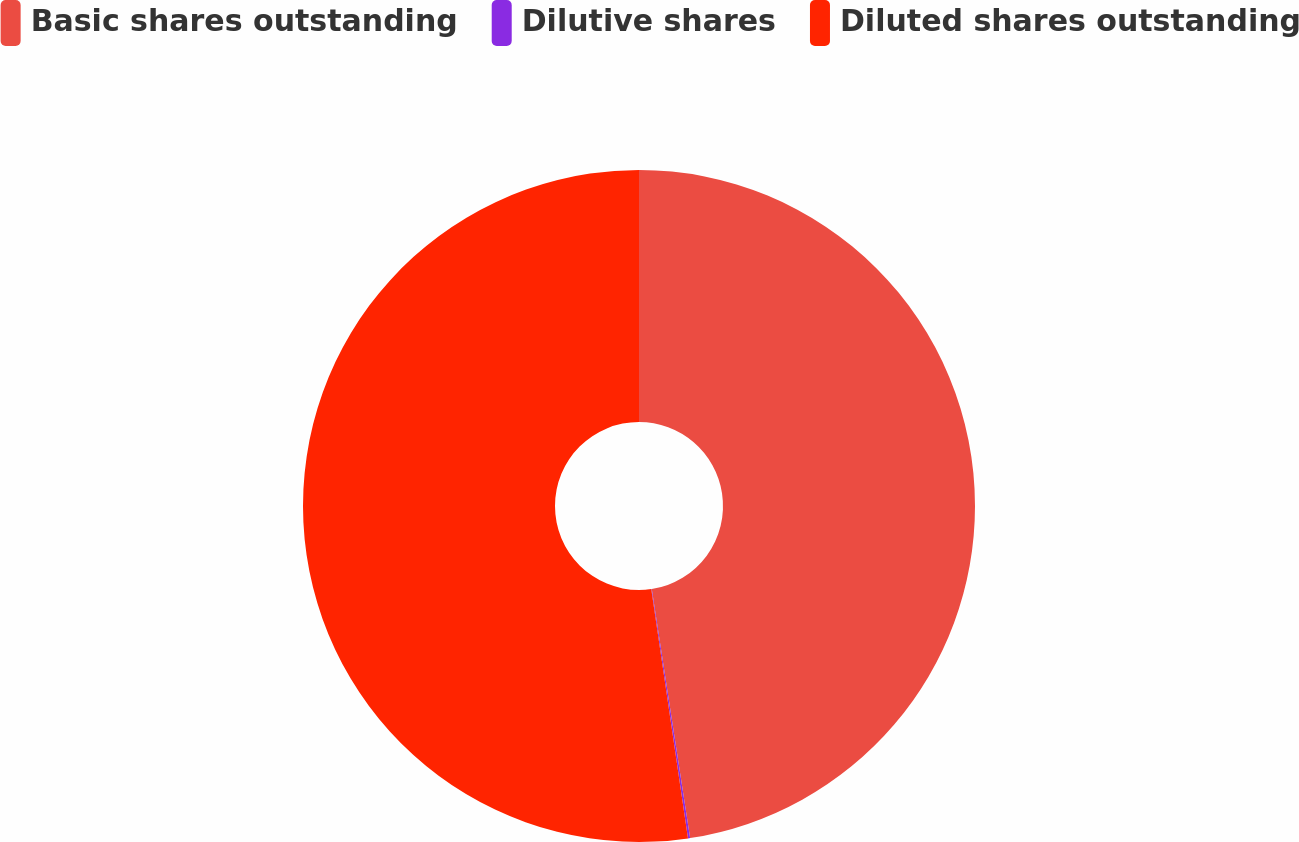Convert chart to OTSL. <chart><loc_0><loc_0><loc_500><loc_500><pie_chart><fcel>Basic shares outstanding<fcel>Dilutive shares<fcel>Diluted shares outstanding<nl><fcel>47.57%<fcel>0.1%<fcel>52.33%<nl></chart> 